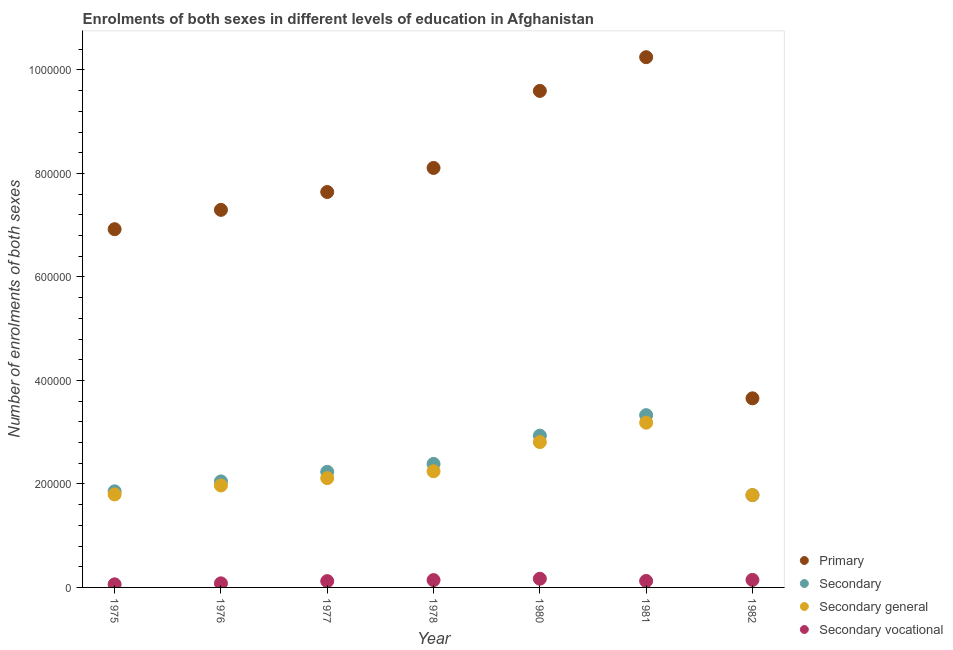Is the number of dotlines equal to the number of legend labels?
Keep it short and to the point. Yes. What is the number of enrolments in primary education in 1977?
Provide a short and direct response. 7.64e+05. Across all years, what is the maximum number of enrolments in primary education?
Offer a very short reply. 1.02e+06. Across all years, what is the minimum number of enrolments in secondary education?
Ensure brevity in your answer.  1.78e+05. In which year was the number of enrolments in secondary education maximum?
Make the answer very short. 1981. In which year was the number of enrolments in secondary education minimum?
Ensure brevity in your answer.  1982. What is the total number of enrolments in secondary education in the graph?
Your response must be concise. 1.66e+06. What is the difference between the number of enrolments in secondary education in 1977 and that in 1982?
Offer a terse response. 4.50e+04. What is the difference between the number of enrolments in primary education in 1975 and the number of enrolments in secondary education in 1977?
Keep it short and to the point. 4.69e+05. What is the average number of enrolments in secondary education per year?
Make the answer very short. 2.37e+05. In the year 1977, what is the difference between the number of enrolments in primary education and number of enrolments in secondary vocational education?
Your answer should be very brief. 7.52e+05. What is the ratio of the number of enrolments in secondary general education in 1976 to that in 1982?
Offer a terse response. 1.1. What is the difference between the highest and the second highest number of enrolments in primary education?
Your answer should be very brief. 6.52e+04. What is the difference between the highest and the lowest number of enrolments in secondary education?
Provide a short and direct response. 1.55e+05. In how many years, is the number of enrolments in primary education greater than the average number of enrolments in primary education taken over all years?
Provide a succinct answer. 4. Is the sum of the number of enrolments in primary education in 1980 and 1981 greater than the maximum number of enrolments in secondary education across all years?
Offer a very short reply. Yes. Is it the case that in every year, the sum of the number of enrolments in primary education and number of enrolments in secondary education is greater than the number of enrolments in secondary general education?
Ensure brevity in your answer.  Yes. Does the number of enrolments in secondary vocational education monotonically increase over the years?
Your answer should be very brief. No. Is the number of enrolments in primary education strictly greater than the number of enrolments in secondary general education over the years?
Offer a very short reply. Yes. Is the number of enrolments in secondary vocational education strictly less than the number of enrolments in primary education over the years?
Give a very brief answer. Yes. How many dotlines are there?
Give a very brief answer. 4. What is the difference between two consecutive major ticks on the Y-axis?
Your answer should be very brief. 2.00e+05. Are the values on the major ticks of Y-axis written in scientific E-notation?
Your answer should be compact. No. Does the graph contain any zero values?
Your answer should be very brief. No. How are the legend labels stacked?
Your answer should be very brief. Vertical. What is the title of the graph?
Your response must be concise. Enrolments of both sexes in different levels of education in Afghanistan. Does "Third 20% of population" appear as one of the legend labels in the graph?
Give a very brief answer. No. What is the label or title of the Y-axis?
Offer a very short reply. Number of enrolments of both sexes. What is the Number of enrolments of both sexes in Primary in 1975?
Your answer should be compact. 6.92e+05. What is the Number of enrolments of both sexes of Secondary in 1975?
Offer a terse response. 1.86e+05. What is the Number of enrolments of both sexes of Secondary general in 1975?
Provide a succinct answer. 1.80e+05. What is the Number of enrolments of both sexes in Secondary vocational in 1975?
Offer a terse response. 5960. What is the Number of enrolments of both sexes in Primary in 1976?
Your response must be concise. 7.30e+05. What is the Number of enrolments of both sexes in Secondary in 1976?
Make the answer very short. 2.05e+05. What is the Number of enrolments of both sexes of Secondary general in 1976?
Your response must be concise. 1.97e+05. What is the Number of enrolments of both sexes of Secondary vocational in 1976?
Keep it short and to the point. 7898. What is the Number of enrolments of both sexes in Primary in 1977?
Give a very brief answer. 7.64e+05. What is the Number of enrolments of both sexes in Secondary in 1977?
Offer a very short reply. 2.23e+05. What is the Number of enrolments of both sexes in Secondary general in 1977?
Your answer should be compact. 2.11e+05. What is the Number of enrolments of both sexes of Secondary vocational in 1977?
Provide a short and direct response. 1.22e+04. What is the Number of enrolments of both sexes in Primary in 1978?
Keep it short and to the point. 8.11e+05. What is the Number of enrolments of both sexes of Secondary in 1978?
Make the answer very short. 2.39e+05. What is the Number of enrolments of both sexes in Secondary general in 1978?
Your response must be concise. 2.25e+05. What is the Number of enrolments of both sexes of Secondary vocational in 1978?
Ensure brevity in your answer.  1.41e+04. What is the Number of enrolments of both sexes in Primary in 1980?
Your answer should be compact. 9.60e+05. What is the Number of enrolments of both sexes of Secondary in 1980?
Provide a succinct answer. 2.93e+05. What is the Number of enrolments of both sexes of Secondary general in 1980?
Provide a succinct answer. 2.81e+05. What is the Number of enrolments of both sexes of Secondary vocational in 1980?
Offer a very short reply. 1.68e+04. What is the Number of enrolments of both sexes in Primary in 1981?
Keep it short and to the point. 1.02e+06. What is the Number of enrolments of both sexes in Secondary in 1981?
Give a very brief answer. 3.33e+05. What is the Number of enrolments of both sexes in Secondary general in 1981?
Your answer should be compact. 3.18e+05. What is the Number of enrolments of both sexes in Secondary vocational in 1981?
Your answer should be compact. 1.24e+04. What is the Number of enrolments of both sexes of Primary in 1982?
Your answer should be compact. 3.65e+05. What is the Number of enrolments of both sexes of Secondary in 1982?
Provide a succinct answer. 1.78e+05. What is the Number of enrolments of both sexes of Secondary general in 1982?
Your response must be concise. 1.78e+05. What is the Number of enrolments of both sexes in Secondary vocational in 1982?
Keep it short and to the point. 1.45e+04. Across all years, what is the maximum Number of enrolments of both sexes in Primary?
Offer a terse response. 1.02e+06. Across all years, what is the maximum Number of enrolments of both sexes of Secondary?
Give a very brief answer. 3.33e+05. Across all years, what is the maximum Number of enrolments of both sexes of Secondary general?
Offer a terse response. 3.18e+05. Across all years, what is the maximum Number of enrolments of both sexes of Secondary vocational?
Ensure brevity in your answer.  1.68e+04. Across all years, what is the minimum Number of enrolments of both sexes in Primary?
Make the answer very short. 3.65e+05. Across all years, what is the minimum Number of enrolments of both sexes in Secondary?
Make the answer very short. 1.78e+05. Across all years, what is the minimum Number of enrolments of both sexes in Secondary general?
Your answer should be very brief. 1.78e+05. Across all years, what is the minimum Number of enrolments of both sexes in Secondary vocational?
Your answer should be compact. 5960. What is the total Number of enrolments of both sexes in Primary in the graph?
Provide a short and direct response. 5.35e+06. What is the total Number of enrolments of both sexes in Secondary in the graph?
Your response must be concise. 1.66e+06. What is the total Number of enrolments of both sexes in Secondary general in the graph?
Make the answer very short. 1.59e+06. What is the total Number of enrolments of both sexes of Secondary vocational in the graph?
Provide a short and direct response. 8.39e+04. What is the difference between the Number of enrolments of both sexes of Primary in 1975 and that in 1976?
Your response must be concise. -3.73e+04. What is the difference between the Number of enrolments of both sexes in Secondary in 1975 and that in 1976?
Ensure brevity in your answer.  -1.92e+04. What is the difference between the Number of enrolments of both sexes in Secondary general in 1975 and that in 1976?
Keep it short and to the point. -1.72e+04. What is the difference between the Number of enrolments of both sexes of Secondary vocational in 1975 and that in 1976?
Your answer should be compact. -1938. What is the difference between the Number of enrolments of both sexes of Primary in 1975 and that in 1977?
Offer a very short reply. -7.18e+04. What is the difference between the Number of enrolments of both sexes in Secondary in 1975 and that in 1977?
Make the answer very short. -3.77e+04. What is the difference between the Number of enrolments of both sexes in Secondary general in 1975 and that in 1977?
Offer a very short reply. -3.14e+04. What is the difference between the Number of enrolments of both sexes of Secondary vocational in 1975 and that in 1977?
Offer a terse response. -6232. What is the difference between the Number of enrolments of both sexes of Primary in 1975 and that in 1978?
Offer a terse response. -1.18e+05. What is the difference between the Number of enrolments of both sexes of Secondary in 1975 and that in 1978?
Your answer should be compact. -5.30e+04. What is the difference between the Number of enrolments of both sexes in Secondary general in 1975 and that in 1978?
Keep it short and to the point. -4.48e+04. What is the difference between the Number of enrolments of both sexes of Secondary vocational in 1975 and that in 1978?
Your response must be concise. -8183. What is the difference between the Number of enrolments of both sexes in Primary in 1975 and that in 1980?
Provide a short and direct response. -2.67e+05. What is the difference between the Number of enrolments of both sexes of Secondary in 1975 and that in 1980?
Your response must be concise. -1.08e+05. What is the difference between the Number of enrolments of both sexes of Secondary general in 1975 and that in 1980?
Provide a short and direct response. -1.01e+05. What is the difference between the Number of enrolments of both sexes of Secondary vocational in 1975 and that in 1980?
Give a very brief answer. -1.08e+04. What is the difference between the Number of enrolments of both sexes in Primary in 1975 and that in 1981?
Keep it short and to the point. -3.32e+05. What is the difference between the Number of enrolments of both sexes of Secondary in 1975 and that in 1981?
Provide a succinct answer. -1.47e+05. What is the difference between the Number of enrolments of both sexes in Secondary general in 1975 and that in 1981?
Make the answer very short. -1.39e+05. What is the difference between the Number of enrolments of both sexes in Secondary vocational in 1975 and that in 1981?
Offer a terse response. -6450. What is the difference between the Number of enrolments of both sexes of Primary in 1975 and that in 1982?
Ensure brevity in your answer.  3.27e+05. What is the difference between the Number of enrolments of both sexes in Secondary in 1975 and that in 1982?
Your response must be concise. 7300. What is the difference between the Number of enrolments of both sexes of Secondary general in 1975 and that in 1982?
Provide a short and direct response. 1340. What is the difference between the Number of enrolments of both sexes of Secondary vocational in 1975 and that in 1982?
Make the answer very short. -8572. What is the difference between the Number of enrolments of both sexes of Primary in 1976 and that in 1977?
Make the answer very short. -3.45e+04. What is the difference between the Number of enrolments of both sexes of Secondary in 1976 and that in 1977?
Provide a short and direct response. -1.85e+04. What is the difference between the Number of enrolments of both sexes in Secondary general in 1976 and that in 1977?
Provide a succinct answer. -1.42e+04. What is the difference between the Number of enrolments of both sexes in Secondary vocational in 1976 and that in 1977?
Ensure brevity in your answer.  -4294. What is the difference between the Number of enrolments of both sexes of Primary in 1976 and that in 1978?
Your answer should be very brief. -8.10e+04. What is the difference between the Number of enrolments of both sexes in Secondary in 1976 and that in 1978?
Give a very brief answer. -3.38e+04. What is the difference between the Number of enrolments of both sexes in Secondary general in 1976 and that in 1978?
Offer a terse response. -2.75e+04. What is the difference between the Number of enrolments of both sexes of Secondary vocational in 1976 and that in 1978?
Offer a very short reply. -6245. What is the difference between the Number of enrolments of both sexes of Primary in 1976 and that in 1980?
Your answer should be very brief. -2.30e+05. What is the difference between the Number of enrolments of both sexes in Secondary in 1976 and that in 1980?
Offer a terse response. -8.84e+04. What is the difference between the Number of enrolments of both sexes in Secondary general in 1976 and that in 1980?
Offer a very short reply. -8.39e+04. What is the difference between the Number of enrolments of both sexes of Secondary vocational in 1976 and that in 1980?
Your answer should be very brief. -8886. What is the difference between the Number of enrolments of both sexes in Primary in 1976 and that in 1981?
Provide a succinct answer. -2.95e+05. What is the difference between the Number of enrolments of both sexes of Secondary in 1976 and that in 1981?
Your response must be concise. -1.28e+05. What is the difference between the Number of enrolments of both sexes of Secondary general in 1976 and that in 1981?
Your response must be concise. -1.21e+05. What is the difference between the Number of enrolments of both sexes in Secondary vocational in 1976 and that in 1981?
Ensure brevity in your answer.  -4512. What is the difference between the Number of enrolments of both sexes of Primary in 1976 and that in 1982?
Your response must be concise. 3.64e+05. What is the difference between the Number of enrolments of both sexes in Secondary in 1976 and that in 1982?
Your response must be concise. 2.65e+04. What is the difference between the Number of enrolments of both sexes of Secondary general in 1976 and that in 1982?
Keep it short and to the point. 1.86e+04. What is the difference between the Number of enrolments of both sexes of Secondary vocational in 1976 and that in 1982?
Your answer should be very brief. -6634. What is the difference between the Number of enrolments of both sexes of Primary in 1977 and that in 1978?
Your response must be concise. -4.65e+04. What is the difference between the Number of enrolments of both sexes of Secondary in 1977 and that in 1978?
Your answer should be compact. -1.53e+04. What is the difference between the Number of enrolments of both sexes in Secondary general in 1977 and that in 1978?
Your answer should be very brief. -1.33e+04. What is the difference between the Number of enrolments of both sexes in Secondary vocational in 1977 and that in 1978?
Your answer should be compact. -1951. What is the difference between the Number of enrolments of both sexes in Primary in 1977 and that in 1980?
Give a very brief answer. -1.95e+05. What is the difference between the Number of enrolments of both sexes of Secondary in 1977 and that in 1980?
Your answer should be very brief. -6.99e+04. What is the difference between the Number of enrolments of both sexes of Secondary general in 1977 and that in 1980?
Make the answer very short. -6.97e+04. What is the difference between the Number of enrolments of both sexes of Secondary vocational in 1977 and that in 1980?
Your answer should be compact. -4592. What is the difference between the Number of enrolments of both sexes in Primary in 1977 and that in 1981?
Your answer should be very brief. -2.61e+05. What is the difference between the Number of enrolments of both sexes of Secondary in 1977 and that in 1981?
Your answer should be compact. -1.10e+05. What is the difference between the Number of enrolments of both sexes of Secondary general in 1977 and that in 1981?
Provide a short and direct response. -1.07e+05. What is the difference between the Number of enrolments of both sexes of Secondary vocational in 1977 and that in 1981?
Your answer should be very brief. -218. What is the difference between the Number of enrolments of both sexes of Primary in 1977 and that in 1982?
Give a very brief answer. 3.99e+05. What is the difference between the Number of enrolments of both sexes in Secondary in 1977 and that in 1982?
Your answer should be compact. 4.50e+04. What is the difference between the Number of enrolments of both sexes in Secondary general in 1977 and that in 1982?
Offer a terse response. 3.28e+04. What is the difference between the Number of enrolments of both sexes in Secondary vocational in 1977 and that in 1982?
Your answer should be very brief. -2340. What is the difference between the Number of enrolments of both sexes in Primary in 1978 and that in 1980?
Your answer should be compact. -1.49e+05. What is the difference between the Number of enrolments of both sexes in Secondary in 1978 and that in 1980?
Make the answer very short. -5.46e+04. What is the difference between the Number of enrolments of both sexes in Secondary general in 1978 and that in 1980?
Keep it short and to the point. -5.64e+04. What is the difference between the Number of enrolments of both sexes of Secondary vocational in 1978 and that in 1980?
Your answer should be very brief. -2641. What is the difference between the Number of enrolments of both sexes in Primary in 1978 and that in 1981?
Ensure brevity in your answer.  -2.14e+05. What is the difference between the Number of enrolments of both sexes of Secondary in 1978 and that in 1981?
Your answer should be compact. -9.43e+04. What is the difference between the Number of enrolments of both sexes of Secondary general in 1978 and that in 1981?
Ensure brevity in your answer.  -9.39e+04. What is the difference between the Number of enrolments of both sexes in Secondary vocational in 1978 and that in 1981?
Provide a succinct answer. 1733. What is the difference between the Number of enrolments of both sexes in Primary in 1978 and that in 1982?
Give a very brief answer. 4.45e+05. What is the difference between the Number of enrolments of both sexes in Secondary in 1978 and that in 1982?
Provide a short and direct response. 6.03e+04. What is the difference between the Number of enrolments of both sexes of Secondary general in 1978 and that in 1982?
Your response must be concise. 4.61e+04. What is the difference between the Number of enrolments of both sexes in Secondary vocational in 1978 and that in 1982?
Keep it short and to the point. -389. What is the difference between the Number of enrolments of both sexes of Primary in 1980 and that in 1981?
Ensure brevity in your answer.  -6.52e+04. What is the difference between the Number of enrolments of both sexes in Secondary in 1980 and that in 1981?
Make the answer very short. -3.96e+04. What is the difference between the Number of enrolments of both sexes of Secondary general in 1980 and that in 1981?
Your response must be concise. -3.75e+04. What is the difference between the Number of enrolments of both sexes of Secondary vocational in 1980 and that in 1981?
Offer a terse response. 4374. What is the difference between the Number of enrolments of both sexes in Primary in 1980 and that in 1982?
Offer a terse response. 5.94e+05. What is the difference between the Number of enrolments of both sexes in Secondary in 1980 and that in 1982?
Provide a succinct answer. 1.15e+05. What is the difference between the Number of enrolments of both sexes in Secondary general in 1980 and that in 1982?
Make the answer very short. 1.02e+05. What is the difference between the Number of enrolments of both sexes in Secondary vocational in 1980 and that in 1982?
Provide a short and direct response. 2252. What is the difference between the Number of enrolments of both sexes of Primary in 1981 and that in 1982?
Make the answer very short. 6.59e+05. What is the difference between the Number of enrolments of both sexes in Secondary in 1981 and that in 1982?
Your response must be concise. 1.55e+05. What is the difference between the Number of enrolments of both sexes in Secondary general in 1981 and that in 1982?
Keep it short and to the point. 1.40e+05. What is the difference between the Number of enrolments of both sexes in Secondary vocational in 1981 and that in 1982?
Keep it short and to the point. -2122. What is the difference between the Number of enrolments of both sexes in Primary in 1975 and the Number of enrolments of both sexes in Secondary in 1976?
Ensure brevity in your answer.  4.87e+05. What is the difference between the Number of enrolments of both sexes in Primary in 1975 and the Number of enrolments of both sexes in Secondary general in 1976?
Keep it short and to the point. 4.95e+05. What is the difference between the Number of enrolments of both sexes of Primary in 1975 and the Number of enrolments of both sexes of Secondary vocational in 1976?
Provide a succinct answer. 6.84e+05. What is the difference between the Number of enrolments of both sexes in Secondary in 1975 and the Number of enrolments of both sexes in Secondary general in 1976?
Your answer should be compact. -1.13e+04. What is the difference between the Number of enrolments of both sexes of Secondary in 1975 and the Number of enrolments of both sexes of Secondary vocational in 1976?
Offer a very short reply. 1.78e+05. What is the difference between the Number of enrolments of both sexes in Secondary general in 1975 and the Number of enrolments of both sexes in Secondary vocational in 1976?
Your response must be concise. 1.72e+05. What is the difference between the Number of enrolments of both sexes of Primary in 1975 and the Number of enrolments of both sexes of Secondary in 1977?
Your response must be concise. 4.69e+05. What is the difference between the Number of enrolments of both sexes of Primary in 1975 and the Number of enrolments of both sexes of Secondary general in 1977?
Offer a terse response. 4.81e+05. What is the difference between the Number of enrolments of both sexes of Primary in 1975 and the Number of enrolments of both sexes of Secondary vocational in 1977?
Your answer should be very brief. 6.80e+05. What is the difference between the Number of enrolments of both sexes in Secondary in 1975 and the Number of enrolments of both sexes in Secondary general in 1977?
Give a very brief answer. -2.55e+04. What is the difference between the Number of enrolments of both sexes in Secondary in 1975 and the Number of enrolments of both sexes in Secondary vocational in 1977?
Offer a very short reply. 1.74e+05. What is the difference between the Number of enrolments of both sexes in Secondary general in 1975 and the Number of enrolments of both sexes in Secondary vocational in 1977?
Ensure brevity in your answer.  1.68e+05. What is the difference between the Number of enrolments of both sexes of Primary in 1975 and the Number of enrolments of both sexes of Secondary in 1978?
Your answer should be compact. 4.54e+05. What is the difference between the Number of enrolments of both sexes in Primary in 1975 and the Number of enrolments of both sexes in Secondary general in 1978?
Your answer should be very brief. 4.68e+05. What is the difference between the Number of enrolments of both sexes of Primary in 1975 and the Number of enrolments of both sexes of Secondary vocational in 1978?
Your answer should be very brief. 6.78e+05. What is the difference between the Number of enrolments of both sexes of Secondary in 1975 and the Number of enrolments of both sexes of Secondary general in 1978?
Your answer should be compact. -3.88e+04. What is the difference between the Number of enrolments of both sexes in Secondary in 1975 and the Number of enrolments of both sexes in Secondary vocational in 1978?
Offer a very short reply. 1.72e+05. What is the difference between the Number of enrolments of both sexes of Secondary general in 1975 and the Number of enrolments of both sexes of Secondary vocational in 1978?
Your answer should be compact. 1.66e+05. What is the difference between the Number of enrolments of both sexes of Primary in 1975 and the Number of enrolments of both sexes of Secondary in 1980?
Keep it short and to the point. 3.99e+05. What is the difference between the Number of enrolments of both sexes in Primary in 1975 and the Number of enrolments of both sexes in Secondary general in 1980?
Ensure brevity in your answer.  4.11e+05. What is the difference between the Number of enrolments of both sexes of Primary in 1975 and the Number of enrolments of both sexes of Secondary vocational in 1980?
Provide a succinct answer. 6.76e+05. What is the difference between the Number of enrolments of both sexes in Secondary in 1975 and the Number of enrolments of both sexes in Secondary general in 1980?
Offer a terse response. -9.52e+04. What is the difference between the Number of enrolments of both sexes of Secondary in 1975 and the Number of enrolments of both sexes of Secondary vocational in 1980?
Your response must be concise. 1.69e+05. What is the difference between the Number of enrolments of both sexes in Secondary general in 1975 and the Number of enrolments of both sexes in Secondary vocational in 1980?
Your answer should be very brief. 1.63e+05. What is the difference between the Number of enrolments of both sexes of Primary in 1975 and the Number of enrolments of both sexes of Secondary in 1981?
Your answer should be compact. 3.59e+05. What is the difference between the Number of enrolments of both sexes in Primary in 1975 and the Number of enrolments of both sexes in Secondary general in 1981?
Make the answer very short. 3.74e+05. What is the difference between the Number of enrolments of both sexes of Primary in 1975 and the Number of enrolments of both sexes of Secondary vocational in 1981?
Provide a succinct answer. 6.80e+05. What is the difference between the Number of enrolments of both sexes in Secondary in 1975 and the Number of enrolments of both sexes in Secondary general in 1981?
Provide a short and direct response. -1.33e+05. What is the difference between the Number of enrolments of both sexes in Secondary in 1975 and the Number of enrolments of both sexes in Secondary vocational in 1981?
Your answer should be compact. 1.73e+05. What is the difference between the Number of enrolments of both sexes of Secondary general in 1975 and the Number of enrolments of both sexes of Secondary vocational in 1981?
Offer a very short reply. 1.67e+05. What is the difference between the Number of enrolments of both sexes in Primary in 1975 and the Number of enrolments of both sexes in Secondary in 1982?
Ensure brevity in your answer.  5.14e+05. What is the difference between the Number of enrolments of both sexes of Primary in 1975 and the Number of enrolments of both sexes of Secondary general in 1982?
Keep it short and to the point. 5.14e+05. What is the difference between the Number of enrolments of both sexes of Primary in 1975 and the Number of enrolments of both sexes of Secondary vocational in 1982?
Make the answer very short. 6.78e+05. What is the difference between the Number of enrolments of both sexes in Secondary in 1975 and the Number of enrolments of both sexes in Secondary general in 1982?
Keep it short and to the point. 7300. What is the difference between the Number of enrolments of both sexes of Secondary in 1975 and the Number of enrolments of both sexes of Secondary vocational in 1982?
Provide a succinct answer. 1.71e+05. What is the difference between the Number of enrolments of both sexes in Secondary general in 1975 and the Number of enrolments of both sexes in Secondary vocational in 1982?
Make the answer very short. 1.65e+05. What is the difference between the Number of enrolments of both sexes in Primary in 1976 and the Number of enrolments of both sexes in Secondary in 1977?
Your response must be concise. 5.06e+05. What is the difference between the Number of enrolments of both sexes in Primary in 1976 and the Number of enrolments of both sexes in Secondary general in 1977?
Provide a succinct answer. 5.18e+05. What is the difference between the Number of enrolments of both sexes in Primary in 1976 and the Number of enrolments of both sexes in Secondary vocational in 1977?
Your answer should be compact. 7.17e+05. What is the difference between the Number of enrolments of both sexes in Secondary in 1976 and the Number of enrolments of both sexes in Secondary general in 1977?
Ensure brevity in your answer.  -6298. What is the difference between the Number of enrolments of both sexes of Secondary in 1976 and the Number of enrolments of both sexes of Secondary vocational in 1977?
Ensure brevity in your answer.  1.93e+05. What is the difference between the Number of enrolments of both sexes of Secondary general in 1976 and the Number of enrolments of both sexes of Secondary vocational in 1977?
Provide a short and direct response. 1.85e+05. What is the difference between the Number of enrolments of both sexes of Primary in 1976 and the Number of enrolments of both sexes of Secondary in 1978?
Keep it short and to the point. 4.91e+05. What is the difference between the Number of enrolments of both sexes of Primary in 1976 and the Number of enrolments of both sexes of Secondary general in 1978?
Your answer should be very brief. 5.05e+05. What is the difference between the Number of enrolments of both sexes in Primary in 1976 and the Number of enrolments of both sexes in Secondary vocational in 1978?
Your response must be concise. 7.16e+05. What is the difference between the Number of enrolments of both sexes of Secondary in 1976 and the Number of enrolments of both sexes of Secondary general in 1978?
Provide a short and direct response. -1.96e+04. What is the difference between the Number of enrolments of both sexes of Secondary in 1976 and the Number of enrolments of both sexes of Secondary vocational in 1978?
Offer a very short reply. 1.91e+05. What is the difference between the Number of enrolments of both sexes in Secondary general in 1976 and the Number of enrolments of both sexes in Secondary vocational in 1978?
Offer a terse response. 1.83e+05. What is the difference between the Number of enrolments of both sexes in Primary in 1976 and the Number of enrolments of both sexes in Secondary in 1980?
Give a very brief answer. 4.36e+05. What is the difference between the Number of enrolments of both sexes of Primary in 1976 and the Number of enrolments of both sexes of Secondary general in 1980?
Provide a short and direct response. 4.49e+05. What is the difference between the Number of enrolments of both sexes in Primary in 1976 and the Number of enrolments of both sexes in Secondary vocational in 1980?
Make the answer very short. 7.13e+05. What is the difference between the Number of enrolments of both sexes in Secondary in 1976 and the Number of enrolments of both sexes in Secondary general in 1980?
Your response must be concise. -7.60e+04. What is the difference between the Number of enrolments of both sexes of Secondary in 1976 and the Number of enrolments of both sexes of Secondary vocational in 1980?
Your answer should be compact. 1.88e+05. What is the difference between the Number of enrolments of both sexes in Secondary general in 1976 and the Number of enrolments of both sexes in Secondary vocational in 1980?
Keep it short and to the point. 1.80e+05. What is the difference between the Number of enrolments of both sexes of Primary in 1976 and the Number of enrolments of both sexes of Secondary in 1981?
Give a very brief answer. 3.97e+05. What is the difference between the Number of enrolments of both sexes in Primary in 1976 and the Number of enrolments of both sexes in Secondary general in 1981?
Ensure brevity in your answer.  4.11e+05. What is the difference between the Number of enrolments of both sexes in Primary in 1976 and the Number of enrolments of both sexes in Secondary vocational in 1981?
Keep it short and to the point. 7.17e+05. What is the difference between the Number of enrolments of both sexes of Secondary in 1976 and the Number of enrolments of both sexes of Secondary general in 1981?
Provide a succinct answer. -1.14e+05. What is the difference between the Number of enrolments of both sexes in Secondary in 1976 and the Number of enrolments of both sexes in Secondary vocational in 1981?
Provide a succinct answer. 1.92e+05. What is the difference between the Number of enrolments of both sexes of Secondary general in 1976 and the Number of enrolments of both sexes of Secondary vocational in 1981?
Make the answer very short. 1.85e+05. What is the difference between the Number of enrolments of both sexes in Primary in 1976 and the Number of enrolments of both sexes in Secondary in 1982?
Give a very brief answer. 5.51e+05. What is the difference between the Number of enrolments of both sexes in Primary in 1976 and the Number of enrolments of both sexes in Secondary general in 1982?
Make the answer very short. 5.51e+05. What is the difference between the Number of enrolments of both sexes of Primary in 1976 and the Number of enrolments of both sexes of Secondary vocational in 1982?
Offer a very short reply. 7.15e+05. What is the difference between the Number of enrolments of both sexes of Secondary in 1976 and the Number of enrolments of both sexes of Secondary general in 1982?
Give a very brief answer. 2.65e+04. What is the difference between the Number of enrolments of both sexes of Secondary in 1976 and the Number of enrolments of both sexes of Secondary vocational in 1982?
Keep it short and to the point. 1.90e+05. What is the difference between the Number of enrolments of both sexes of Secondary general in 1976 and the Number of enrolments of both sexes of Secondary vocational in 1982?
Offer a very short reply. 1.82e+05. What is the difference between the Number of enrolments of both sexes of Primary in 1977 and the Number of enrolments of both sexes of Secondary in 1978?
Your answer should be very brief. 5.26e+05. What is the difference between the Number of enrolments of both sexes in Primary in 1977 and the Number of enrolments of both sexes in Secondary general in 1978?
Give a very brief answer. 5.40e+05. What is the difference between the Number of enrolments of both sexes in Primary in 1977 and the Number of enrolments of both sexes in Secondary vocational in 1978?
Provide a short and direct response. 7.50e+05. What is the difference between the Number of enrolments of both sexes of Secondary in 1977 and the Number of enrolments of both sexes of Secondary general in 1978?
Provide a short and direct response. -1152. What is the difference between the Number of enrolments of both sexes of Secondary in 1977 and the Number of enrolments of both sexes of Secondary vocational in 1978?
Your response must be concise. 2.09e+05. What is the difference between the Number of enrolments of both sexes of Secondary general in 1977 and the Number of enrolments of both sexes of Secondary vocational in 1978?
Keep it short and to the point. 1.97e+05. What is the difference between the Number of enrolments of both sexes of Primary in 1977 and the Number of enrolments of both sexes of Secondary in 1980?
Give a very brief answer. 4.71e+05. What is the difference between the Number of enrolments of both sexes of Primary in 1977 and the Number of enrolments of both sexes of Secondary general in 1980?
Provide a succinct answer. 4.83e+05. What is the difference between the Number of enrolments of both sexes in Primary in 1977 and the Number of enrolments of both sexes in Secondary vocational in 1980?
Provide a short and direct response. 7.47e+05. What is the difference between the Number of enrolments of both sexes of Secondary in 1977 and the Number of enrolments of both sexes of Secondary general in 1980?
Offer a very short reply. -5.75e+04. What is the difference between the Number of enrolments of both sexes in Secondary in 1977 and the Number of enrolments of both sexes in Secondary vocational in 1980?
Ensure brevity in your answer.  2.07e+05. What is the difference between the Number of enrolments of both sexes of Secondary general in 1977 and the Number of enrolments of both sexes of Secondary vocational in 1980?
Your answer should be compact. 1.94e+05. What is the difference between the Number of enrolments of both sexes of Primary in 1977 and the Number of enrolments of both sexes of Secondary in 1981?
Offer a very short reply. 4.31e+05. What is the difference between the Number of enrolments of both sexes of Primary in 1977 and the Number of enrolments of both sexes of Secondary general in 1981?
Ensure brevity in your answer.  4.46e+05. What is the difference between the Number of enrolments of both sexes in Primary in 1977 and the Number of enrolments of both sexes in Secondary vocational in 1981?
Your answer should be very brief. 7.52e+05. What is the difference between the Number of enrolments of both sexes of Secondary in 1977 and the Number of enrolments of both sexes of Secondary general in 1981?
Ensure brevity in your answer.  -9.50e+04. What is the difference between the Number of enrolments of both sexes of Secondary in 1977 and the Number of enrolments of both sexes of Secondary vocational in 1981?
Ensure brevity in your answer.  2.11e+05. What is the difference between the Number of enrolments of both sexes of Secondary general in 1977 and the Number of enrolments of both sexes of Secondary vocational in 1981?
Give a very brief answer. 1.99e+05. What is the difference between the Number of enrolments of both sexes of Primary in 1977 and the Number of enrolments of both sexes of Secondary in 1982?
Your answer should be very brief. 5.86e+05. What is the difference between the Number of enrolments of both sexes of Primary in 1977 and the Number of enrolments of both sexes of Secondary general in 1982?
Your answer should be very brief. 5.86e+05. What is the difference between the Number of enrolments of both sexes in Primary in 1977 and the Number of enrolments of both sexes in Secondary vocational in 1982?
Ensure brevity in your answer.  7.50e+05. What is the difference between the Number of enrolments of both sexes in Secondary in 1977 and the Number of enrolments of both sexes in Secondary general in 1982?
Make the answer very short. 4.50e+04. What is the difference between the Number of enrolments of both sexes in Secondary in 1977 and the Number of enrolments of both sexes in Secondary vocational in 1982?
Provide a succinct answer. 2.09e+05. What is the difference between the Number of enrolments of both sexes of Secondary general in 1977 and the Number of enrolments of both sexes of Secondary vocational in 1982?
Offer a terse response. 1.97e+05. What is the difference between the Number of enrolments of both sexes of Primary in 1978 and the Number of enrolments of both sexes of Secondary in 1980?
Offer a very short reply. 5.17e+05. What is the difference between the Number of enrolments of both sexes in Primary in 1978 and the Number of enrolments of both sexes in Secondary general in 1980?
Give a very brief answer. 5.30e+05. What is the difference between the Number of enrolments of both sexes in Primary in 1978 and the Number of enrolments of both sexes in Secondary vocational in 1980?
Ensure brevity in your answer.  7.94e+05. What is the difference between the Number of enrolments of both sexes in Secondary in 1978 and the Number of enrolments of both sexes in Secondary general in 1980?
Your answer should be very brief. -4.22e+04. What is the difference between the Number of enrolments of both sexes of Secondary in 1978 and the Number of enrolments of both sexes of Secondary vocational in 1980?
Offer a very short reply. 2.22e+05. What is the difference between the Number of enrolments of both sexes in Secondary general in 1978 and the Number of enrolments of both sexes in Secondary vocational in 1980?
Give a very brief answer. 2.08e+05. What is the difference between the Number of enrolments of both sexes in Primary in 1978 and the Number of enrolments of both sexes in Secondary in 1981?
Ensure brevity in your answer.  4.78e+05. What is the difference between the Number of enrolments of both sexes in Primary in 1978 and the Number of enrolments of both sexes in Secondary general in 1981?
Ensure brevity in your answer.  4.92e+05. What is the difference between the Number of enrolments of both sexes in Primary in 1978 and the Number of enrolments of both sexes in Secondary vocational in 1981?
Your response must be concise. 7.98e+05. What is the difference between the Number of enrolments of both sexes of Secondary in 1978 and the Number of enrolments of both sexes of Secondary general in 1981?
Offer a terse response. -7.97e+04. What is the difference between the Number of enrolments of both sexes in Secondary in 1978 and the Number of enrolments of both sexes in Secondary vocational in 1981?
Your answer should be very brief. 2.26e+05. What is the difference between the Number of enrolments of both sexes in Secondary general in 1978 and the Number of enrolments of both sexes in Secondary vocational in 1981?
Provide a succinct answer. 2.12e+05. What is the difference between the Number of enrolments of both sexes in Primary in 1978 and the Number of enrolments of both sexes in Secondary in 1982?
Your answer should be very brief. 6.32e+05. What is the difference between the Number of enrolments of both sexes of Primary in 1978 and the Number of enrolments of both sexes of Secondary general in 1982?
Your response must be concise. 6.32e+05. What is the difference between the Number of enrolments of both sexes of Primary in 1978 and the Number of enrolments of both sexes of Secondary vocational in 1982?
Make the answer very short. 7.96e+05. What is the difference between the Number of enrolments of both sexes of Secondary in 1978 and the Number of enrolments of both sexes of Secondary general in 1982?
Provide a short and direct response. 6.03e+04. What is the difference between the Number of enrolments of both sexes of Secondary in 1978 and the Number of enrolments of both sexes of Secondary vocational in 1982?
Your answer should be compact. 2.24e+05. What is the difference between the Number of enrolments of both sexes in Secondary general in 1978 and the Number of enrolments of both sexes in Secondary vocational in 1982?
Ensure brevity in your answer.  2.10e+05. What is the difference between the Number of enrolments of both sexes in Primary in 1980 and the Number of enrolments of both sexes in Secondary in 1981?
Give a very brief answer. 6.27e+05. What is the difference between the Number of enrolments of both sexes of Primary in 1980 and the Number of enrolments of both sexes of Secondary general in 1981?
Ensure brevity in your answer.  6.41e+05. What is the difference between the Number of enrolments of both sexes in Primary in 1980 and the Number of enrolments of both sexes in Secondary vocational in 1981?
Your answer should be very brief. 9.47e+05. What is the difference between the Number of enrolments of both sexes in Secondary in 1980 and the Number of enrolments of both sexes in Secondary general in 1981?
Offer a very short reply. -2.51e+04. What is the difference between the Number of enrolments of both sexes of Secondary in 1980 and the Number of enrolments of both sexes of Secondary vocational in 1981?
Your answer should be compact. 2.81e+05. What is the difference between the Number of enrolments of both sexes of Secondary general in 1980 and the Number of enrolments of both sexes of Secondary vocational in 1981?
Offer a terse response. 2.68e+05. What is the difference between the Number of enrolments of both sexes in Primary in 1980 and the Number of enrolments of both sexes in Secondary in 1982?
Your response must be concise. 7.81e+05. What is the difference between the Number of enrolments of both sexes in Primary in 1980 and the Number of enrolments of both sexes in Secondary general in 1982?
Keep it short and to the point. 7.81e+05. What is the difference between the Number of enrolments of both sexes in Primary in 1980 and the Number of enrolments of both sexes in Secondary vocational in 1982?
Your answer should be very brief. 9.45e+05. What is the difference between the Number of enrolments of both sexes of Secondary in 1980 and the Number of enrolments of both sexes of Secondary general in 1982?
Your answer should be compact. 1.15e+05. What is the difference between the Number of enrolments of both sexes in Secondary in 1980 and the Number of enrolments of both sexes in Secondary vocational in 1982?
Provide a short and direct response. 2.79e+05. What is the difference between the Number of enrolments of both sexes of Secondary general in 1980 and the Number of enrolments of both sexes of Secondary vocational in 1982?
Provide a short and direct response. 2.66e+05. What is the difference between the Number of enrolments of both sexes in Primary in 1981 and the Number of enrolments of both sexes in Secondary in 1982?
Keep it short and to the point. 8.46e+05. What is the difference between the Number of enrolments of both sexes in Primary in 1981 and the Number of enrolments of both sexes in Secondary general in 1982?
Ensure brevity in your answer.  8.46e+05. What is the difference between the Number of enrolments of both sexes of Primary in 1981 and the Number of enrolments of both sexes of Secondary vocational in 1982?
Your answer should be compact. 1.01e+06. What is the difference between the Number of enrolments of both sexes of Secondary in 1981 and the Number of enrolments of both sexes of Secondary general in 1982?
Give a very brief answer. 1.55e+05. What is the difference between the Number of enrolments of both sexes in Secondary in 1981 and the Number of enrolments of both sexes in Secondary vocational in 1982?
Provide a succinct answer. 3.18e+05. What is the difference between the Number of enrolments of both sexes of Secondary general in 1981 and the Number of enrolments of both sexes of Secondary vocational in 1982?
Your response must be concise. 3.04e+05. What is the average Number of enrolments of both sexes in Primary per year?
Your answer should be very brief. 7.64e+05. What is the average Number of enrolments of both sexes in Secondary per year?
Make the answer very short. 2.37e+05. What is the average Number of enrolments of both sexes of Secondary general per year?
Your response must be concise. 2.27e+05. What is the average Number of enrolments of both sexes in Secondary vocational per year?
Give a very brief answer. 1.20e+04. In the year 1975, what is the difference between the Number of enrolments of both sexes of Primary and Number of enrolments of both sexes of Secondary?
Your answer should be compact. 5.07e+05. In the year 1975, what is the difference between the Number of enrolments of both sexes in Primary and Number of enrolments of both sexes in Secondary general?
Provide a succinct answer. 5.13e+05. In the year 1975, what is the difference between the Number of enrolments of both sexes of Primary and Number of enrolments of both sexes of Secondary vocational?
Keep it short and to the point. 6.86e+05. In the year 1975, what is the difference between the Number of enrolments of both sexes in Secondary and Number of enrolments of both sexes in Secondary general?
Your response must be concise. 5960. In the year 1975, what is the difference between the Number of enrolments of both sexes of Secondary and Number of enrolments of both sexes of Secondary vocational?
Keep it short and to the point. 1.80e+05. In the year 1975, what is the difference between the Number of enrolments of both sexes in Secondary general and Number of enrolments of both sexes in Secondary vocational?
Offer a very short reply. 1.74e+05. In the year 1976, what is the difference between the Number of enrolments of both sexes of Primary and Number of enrolments of both sexes of Secondary?
Offer a very short reply. 5.25e+05. In the year 1976, what is the difference between the Number of enrolments of both sexes in Primary and Number of enrolments of both sexes in Secondary general?
Give a very brief answer. 5.33e+05. In the year 1976, what is the difference between the Number of enrolments of both sexes of Primary and Number of enrolments of both sexes of Secondary vocational?
Your answer should be compact. 7.22e+05. In the year 1976, what is the difference between the Number of enrolments of both sexes of Secondary and Number of enrolments of both sexes of Secondary general?
Ensure brevity in your answer.  7898. In the year 1976, what is the difference between the Number of enrolments of both sexes in Secondary and Number of enrolments of both sexes in Secondary vocational?
Provide a succinct answer. 1.97e+05. In the year 1976, what is the difference between the Number of enrolments of both sexes of Secondary general and Number of enrolments of both sexes of Secondary vocational?
Your response must be concise. 1.89e+05. In the year 1977, what is the difference between the Number of enrolments of both sexes in Primary and Number of enrolments of both sexes in Secondary?
Your answer should be compact. 5.41e+05. In the year 1977, what is the difference between the Number of enrolments of both sexes of Primary and Number of enrolments of both sexes of Secondary general?
Offer a terse response. 5.53e+05. In the year 1977, what is the difference between the Number of enrolments of both sexes of Primary and Number of enrolments of both sexes of Secondary vocational?
Provide a succinct answer. 7.52e+05. In the year 1977, what is the difference between the Number of enrolments of both sexes in Secondary and Number of enrolments of both sexes in Secondary general?
Ensure brevity in your answer.  1.22e+04. In the year 1977, what is the difference between the Number of enrolments of both sexes of Secondary and Number of enrolments of both sexes of Secondary vocational?
Ensure brevity in your answer.  2.11e+05. In the year 1977, what is the difference between the Number of enrolments of both sexes in Secondary general and Number of enrolments of both sexes in Secondary vocational?
Your response must be concise. 1.99e+05. In the year 1978, what is the difference between the Number of enrolments of both sexes in Primary and Number of enrolments of both sexes in Secondary?
Offer a terse response. 5.72e+05. In the year 1978, what is the difference between the Number of enrolments of both sexes in Primary and Number of enrolments of both sexes in Secondary general?
Provide a short and direct response. 5.86e+05. In the year 1978, what is the difference between the Number of enrolments of both sexes of Primary and Number of enrolments of both sexes of Secondary vocational?
Offer a terse response. 7.97e+05. In the year 1978, what is the difference between the Number of enrolments of both sexes in Secondary and Number of enrolments of both sexes in Secondary general?
Keep it short and to the point. 1.41e+04. In the year 1978, what is the difference between the Number of enrolments of both sexes of Secondary and Number of enrolments of both sexes of Secondary vocational?
Provide a short and direct response. 2.25e+05. In the year 1978, what is the difference between the Number of enrolments of both sexes of Secondary general and Number of enrolments of both sexes of Secondary vocational?
Your answer should be very brief. 2.10e+05. In the year 1980, what is the difference between the Number of enrolments of both sexes in Primary and Number of enrolments of both sexes in Secondary?
Provide a short and direct response. 6.66e+05. In the year 1980, what is the difference between the Number of enrolments of both sexes in Primary and Number of enrolments of both sexes in Secondary general?
Your answer should be very brief. 6.79e+05. In the year 1980, what is the difference between the Number of enrolments of both sexes of Primary and Number of enrolments of both sexes of Secondary vocational?
Your answer should be very brief. 9.43e+05. In the year 1980, what is the difference between the Number of enrolments of both sexes of Secondary and Number of enrolments of both sexes of Secondary general?
Ensure brevity in your answer.  1.24e+04. In the year 1980, what is the difference between the Number of enrolments of both sexes in Secondary and Number of enrolments of both sexes in Secondary vocational?
Offer a very short reply. 2.77e+05. In the year 1980, what is the difference between the Number of enrolments of both sexes of Secondary general and Number of enrolments of both sexes of Secondary vocational?
Your answer should be compact. 2.64e+05. In the year 1981, what is the difference between the Number of enrolments of both sexes of Primary and Number of enrolments of both sexes of Secondary?
Ensure brevity in your answer.  6.92e+05. In the year 1981, what is the difference between the Number of enrolments of both sexes in Primary and Number of enrolments of both sexes in Secondary general?
Offer a very short reply. 7.06e+05. In the year 1981, what is the difference between the Number of enrolments of both sexes of Primary and Number of enrolments of both sexes of Secondary vocational?
Provide a short and direct response. 1.01e+06. In the year 1981, what is the difference between the Number of enrolments of both sexes in Secondary and Number of enrolments of both sexes in Secondary general?
Offer a very short reply. 1.45e+04. In the year 1981, what is the difference between the Number of enrolments of both sexes of Secondary and Number of enrolments of both sexes of Secondary vocational?
Your response must be concise. 3.21e+05. In the year 1981, what is the difference between the Number of enrolments of both sexes in Secondary general and Number of enrolments of both sexes in Secondary vocational?
Give a very brief answer. 3.06e+05. In the year 1982, what is the difference between the Number of enrolments of both sexes of Primary and Number of enrolments of both sexes of Secondary?
Make the answer very short. 1.87e+05. In the year 1982, what is the difference between the Number of enrolments of both sexes of Primary and Number of enrolments of both sexes of Secondary general?
Make the answer very short. 1.87e+05. In the year 1982, what is the difference between the Number of enrolments of both sexes in Primary and Number of enrolments of both sexes in Secondary vocational?
Give a very brief answer. 3.51e+05. In the year 1982, what is the difference between the Number of enrolments of both sexes of Secondary and Number of enrolments of both sexes of Secondary general?
Offer a very short reply. 0. In the year 1982, what is the difference between the Number of enrolments of both sexes of Secondary and Number of enrolments of both sexes of Secondary vocational?
Offer a terse response. 1.64e+05. In the year 1982, what is the difference between the Number of enrolments of both sexes of Secondary general and Number of enrolments of both sexes of Secondary vocational?
Ensure brevity in your answer.  1.64e+05. What is the ratio of the Number of enrolments of both sexes of Primary in 1975 to that in 1976?
Give a very brief answer. 0.95. What is the ratio of the Number of enrolments of both sexes in Secondary in 1975 to that in 1976?
Offer a terse response. 0.91. What is the ratio of the Number of enrolments of both sexes in Secondary general in 1975 to that in 1976?
Your answer should be compact. 0.91. What is the ratio of the Number of enrolments of both sexes of Secondary vocational in 1975 to that in 1976?
Ensure brevity in your answer.  0.75. What is the ratio of the Number of enrolments of both sexes in Primary in 1975 to that in 1977?
Ensure brevity in your answer.  0.91. What is the ratio of the Number of enrolments of both sexes in Secondary in 1975 to that in 1977?
Your answer should be very brief. 0.83. What is the ratio of the Number of enrolments of both sexes of Secondary general in 1975 to that in 1977?
Make the answer very short. 0.85. What is the ratio of the Number of enrolments of both sexes of Secondary vocational in 1975 to that in 1977?
Provide a short and direct response. 0.49. What is the ratio of the Number of enrolments of both sexes in Primary in 1975 to that in 1978?
Give a very brief answer. 0.85. What is the ratio of the Number of enrolments of both sexes of Secondary in 1975 to that in 1978?
Give a very brief answer. 0.78. What is the ratio of the Number of enrolments of both sexes of Secondary general in 1975 to that in 1978?
Offer a terse response. 0.8. What is the ratio of the Number of enrolments of both sexes in Secondary vocational in 1975 to that in 1978?
Make the answer very short. 0.42. What is the ratio of the Number of enrolments of both sexes in Primary in 1975 to that in 1980?
Provide a succinct answer. 0.72. What is the ratio of the Number of enrolments of both sexes in Secondary in 1975 to that in 1980?
Give a very brief answer. 0.63. What is the ratio of the Number of enrolments of both sexes in Secondary general in 1975 to that in 1980?
Provide a succinct answer. 0.64. What is the ratio of the Number of enrolments of both sexes of Secondary vocational in 1975 to that in 1980?
Offer a very short reply. 0.36. What is the ratio of the Number of enrolments of both sexes in Primary in 1975 to that in 1981?
Your answer should be compact. 0.68. What is the ratio of the Number of enrolments of both sexes in Secondary in 1975 to that in 1981?
Ensure brevity in your answer.  0.56. What is the ratio of the Number of enrolments of both sexes in Secondary general in 1975 to that in 1981?
Offer a terse response. 0.56. What is the ratio of the Number of enrolments of both sexes in Secondary vocational in 1975 to that in 1981?
Your response must be concise. 0.48. What is the ratio of the Number of enrolments of both sexes in Primary in 1975 to that in 1982?
Your answer should be compact. 1.89. What is the ratio of the Number of enrolments of both sexes in Secondary in 1975 to that in 1982?
Your answer should be compact. 1.04. What is the ratio of the Number of enrolments of both sexes in Secondary general in 1975 to that in 1982?
Give a very brief answer. 1.01. What is the ratio of the Number of enrolments of both sexes in Secondary vocational in 1975 to that in 1982?
Ensure brevity in your answer.  0.41. What is the ratio of the Number of enrolments of both sexes in Primary in 1976 to that in 1977?
Provide a succinct answer. 0.95. What is the ratio of the Number of enrolments of both sexes in Secondary in 1976 to that in 1977?
Ensure brevity in your answer.  0.92. What is the ratio of the Number of enrolments of both sexes of Secondary general in 1976 to that in 1977?
Your answer should be very brief. 0.93. What is the ratio of the Number of enrolments of both sexes in Secondary vocational in 1976 to that in 1977?
Your answer should be very brief. 0.65. What is the ratio of the Number of enrolments of both sexes in Primary in 1976 to that in 1978?
Provide a succinct answer. 0.9. What is the ratio of the Number of enrolments of both sexes of Secondary in 1976 to that in 1978?
Your answer should be compact. 0.86. What is the ratio of the Number of enrolments of both sexes in Secondary general in 1976 to that in 1978?
Your answer should be compact. 0.88. What is the ratio of the Number of enrolments of both sexes in Secondary vocational in 1976 to that in 1978?
Keep it short and to the point. 0.56. What is the ratio of the Number of enrolments of both sexes of Primary in 1976 to that in 1980?
Give a very brief answer. 0.76. What is the ratio of the Number of enrolments of both sexes of Secondary in 1976 to that in 1980?
Keep it short and to the point. 0.7. What is the ratio of the Number of enrolments of both sexes in Secondary general in 1976 to that in 1980?
Offer a very short reply. 0.7. What is the ratio of the Number of enrolments of both sexes in Secondary vocational in 1976 to that in 1980?
Your response must be concise. 0.47. What is the ratio of the Number of enrolments of both sexes in Primary in 1976 to that in 1981?
Make the answer very short. 0.71. What is the ratio of the Number of enrolments of both sexes of Secondary in 1976 to that in 1981?
Make the answer very short. 0.62. What is the ratio of the Number of enrolments of both sexes in Secondary general in 1976 to that in 1981?
Offer a terse response. 0.62. What is the ratio of the Number of enrolments of both sexes in Secondary vocational in 1976 to that in 1981?
Ensure brevity in your answer.  0.64. What is the ratio of the Number of enrolments of both sexes of Primary in 1976 to that in 1982?
Provide a succinct answer. 2. What is the ratio of the Number of enrolments of both sexes of Secondary in 1976 to that in 1982?
Give a very brief answer. 1.15. What is the ratio of the Number of enrolments of both sexes in Secondary general in 1976 to that in 1982?
Your answer should be very brief. 1.1. What is the ratio of the Number of enrolments of both sexes in Secondary vocational in 1976 to that in 1982?
Keep it short and to the point. 0.54. What is the ratio of the Number of enrolments of both sexes in Primary in 1977 to that in 1978?
Make the answer very short. 0.94. What is the ratio of the Number of enrolments of both sexes of Secondary in 1977 to that in 1978?
Your response must be concise. 0.94. What is the ratio of the Number of enrolments of both sexes of Secondary general in 1977 to that in 1978?
Your answer should be compact. 0.94. What is the ratio of the Number of enrolments of both sexes in Secondary vocational in 1977 to that in 1978?
Offer a very short reply. 0.86. What is the ratio of the Number of enrolments of both sexes in Primary in 1977 to that in 1980?
Your response must be concise. 0.8. What is the ratio of the Number of enrolments of both sexes in Secondary in 1977 to that in 1980?
Offer a very short reply. 0.76. What is the ratio of the Number of enrolments of both sexes of Secondary general in 1977 to that in 1980?
Offer a very short reply. 0.75. What is the ratio of the Number of enrolments of both sexes in Secondary vocational in 1977 to that in 1980?
Provide a succinct answer. 0.73. What is the ratio of the Number of enrolments of both sexes of Primary in 1977 to that in 1981?
Make the answer very short. 0.75. What is the ratio of the Number of enrolments of both sexes of Secondary in 1977 to that in 1981?
Provide a succinct answer. 0.67. What is the ratio of the Number of enrolments of both sexes of Secondary general in 1977 to that in 1981?
Your response must be concise. 0.66. What is the ratio of the Number of enrolments of both sexes of Secondary vocational in 1977 to that in 1981?
Offer a terse response. 0.98. What is the ratio of the Number of enrolments of both sexes in Primary in 1977 to that in 1982?
Ensure brevity in your answer.  2.09. What is the ratio of the Number of enrolments of both sexes of Secondary in 1977 to that in 1982?
Give a very brief answer. 1.25. What is the ratio of the Number of enrolments of both sexes of Secondary general in 1977 to that in 1982?
Ensure brevity in your answer.  1.18. What is the ratio of the Number of enrolments of both sexes in Secondary vocational in 1977 to that in 1982?
Ensure brevity in your answer.  0.84. What is the ratio of the Number of enrolments of both sexes in Primary in 1978 to that in 1980?
Make the answer very short. 0.84. What is the ratio of the Number of enrolments of both sexes of Secondary in 1978 to that in 1980?
Provide a short and direct response. 0.81. What is the ratio of the Number of enrolments of both sexes in Secondary general in 1978 to that in 1980?
Provide a short and direct response. 0.8. What is the ratio of the Number of enrolments of both sexes of Secondary vocational in 1978 to that in 1980?
Give a very brief answer. 0.84. What is the ratio of the Number of enrolments of both sexes in Primary in 1978 to that in 1981?
Ensure brevity in your answer.  0.79. What is the ratio of the Number of enrolments of both sexes of Secondary in 1978 to that in 1981?
Provide a succinct answer. 0.72. What is the ratio of the Number of enrolments of both sexes of Secondary general in 1978 to that in 1981?
Offer a terse response. 0.71. What is the ratio of the Number of enrolments of both sexes in Secondary vocational in 1978 to that in 1981?
Make the answer very short. 1.14. What is the ratio of the Number of enrolments of both sexes of Primary in 1978 to that in 1982?
Your answer should be very brief. 2.22. What is the ratio of the Number of enrolments of both sexes of Secondary in 1978 to that in 1982?
Your answer should be very brief. 1.34. What is the ratio of the Number of enrolments of both sexes in Secondary general in 1978 to that in 1982?
Provide a short and direct response. 1.26. What is the ratio of the Number of enrolments of both sexes of Secondary vocational in 1978 to that in 1982?
Your response must be concise. 0.97. What is the ratio of the Number of enrolments of both sexes in Primary in 1980 to that in 1981?
Provide a short and direct response. 0.94. What is the ratio of the Number of enrolments of both sexes of Secondary in 1980 to that in 1981?
Make the answer very short. 0.88. What is the ratio of the Number of enrolments of both sexes of Secondary general in 1980 to that in 1981?
Provide a short and direct response. 0.88. What is the ratio of the Number of enrolments of both sexes of Secondary vocational in 1980 to that in 1981?
Make the answer very short. 1.35. What is the ratio of the Number of enrolments of both sexes of Primary in 1980 to that in 1982?
Ensure brevity in your answer.  2.63. What is the ratio of the Number of enrolments of both sexes in Secondary in 1980 to that in 1982?
Keep it short and to the point. 1.64. What is the ratio of the Number of enrolments of both sexes in Secondary general in 1980 to that in 1982?
Provide a succinct answer. 1.57. What is the ratio of the Number of enrolments of both sexes in Secondary vocational in 1980 to that in 1982?
Give a very brief answer. 1.16. What is the ratio of the Number of enrolments of both sexes in Primary in 1981 to that in 1982?
Your answer should be very brief. 2.8. What is the ratio of the Number of enrolments of both sexes of Secondary in 1981 to that in 1982?
Your answer should be very brief. 1.87. What is the ratio of the Number of enrolments of both sexes in Secondary general in 1981 to that in 1982?
Offer a terse response. 1.78. What is the ratio of the Number of enrolments of both sexes in Secondary vocational in 1981 to that in 1982?
Ensure brevity in your answer.  0.85. What is the difference between the highest and the second highest Number of enrolments of both sexes in Primary?
Your answer should be compact. 6.52e+04. What is the difference between the highest and the second highest Number of enrolments of both sexes of Secondary?
Provide a succinct answer. 3.96e+04. What is the difference between the highest and the second highest Number of enrolments of both sexes of Secondary general?
Your response must be concise. 3.75e+04. What is the difference between the highest and the second highest Number of enrolments of both sexes of Secondary vocational?
Offer a terse response. 2252. What is the difference between the highest and the lowest Number of enrolments of both sexes in Primary?
Your answer should be very brief. 6.59e+05. What is the difference between the highest and the lowest Number of enrolments of both sexes of Secondary?
Make the answer very short. 1.55e+05. What is the difference between the highest and the lowest Number of enrolments of both sexes of Secondary general?
Offer a terse response. 1.40e+05. What is the difference between the highest and the lowest Number of enrolments of both sexes in Secondary vocational?
Make the answer very short. 1.08e+04. 